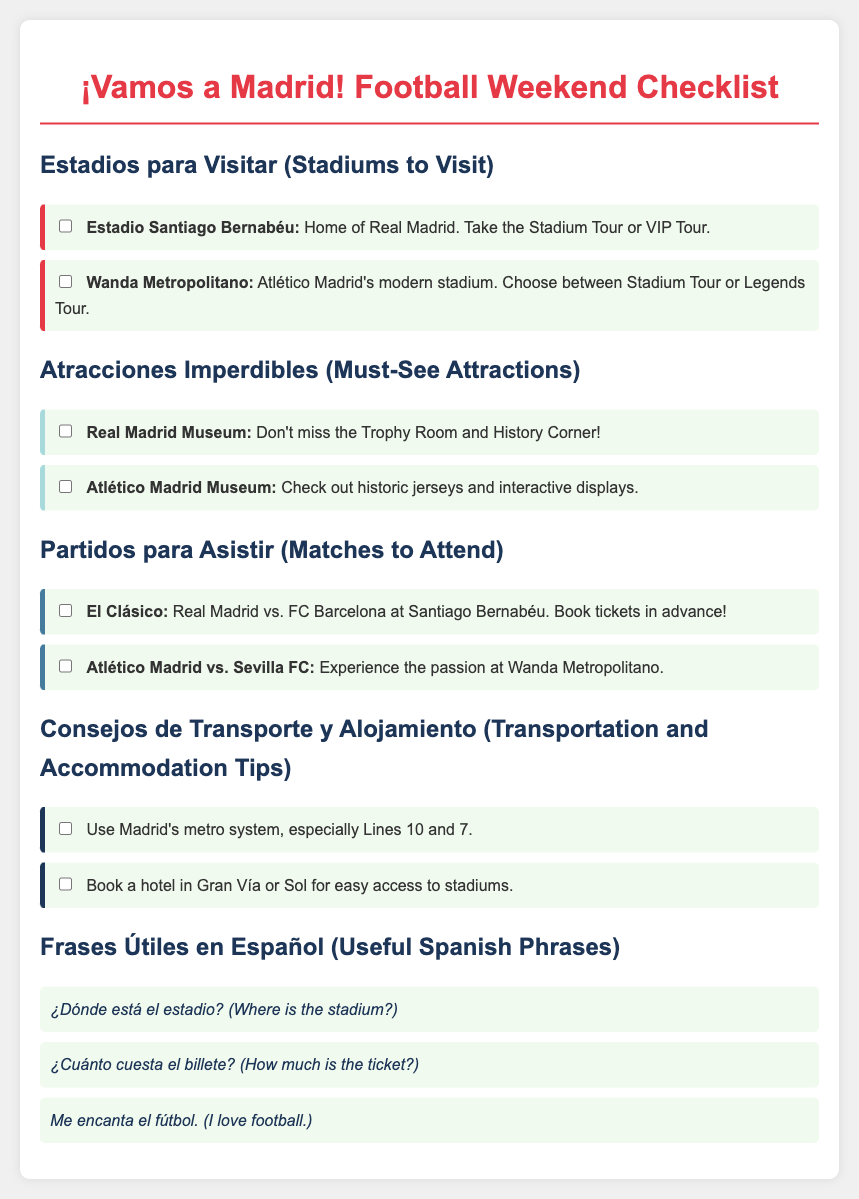What is the home stadium of Real Madrid? The document states that Santiago Bernabéu is the home of Real Madrid.
Answer: Estadio Santiago Bernabéu Which two stadiums are mentioned to visit? The document lists Estadio Santiago Bernabéu and Wanda Metropolitano as stadiums to visit.
Answer: Estadio Santiago Bernabéu and Wanda Metropolitano What is a must-see attraction related to Real Madrid? The document indicates that the Real Madrid Museum is a must-see attraction with specific highlights.
Answer: Real Madrid Museum Which famous match takes place at Santiago Bernabéu? The document mentions El Clásico as the famous match that takes place at Santiago Bernabéu.
Answer: El Clásico What tip does the document give regarding transportation? The document advises using Madrid's metro system, particularly highlighting specific lines.
Answer: Use Madrid's metro system How should one book accommodation for easy stadium access? The document suggests booking a hotel in certain areas for convenience in accessing stadiums.
Answer: Gran Vía or Sol What useful phrase translates to "I love football"? The document provides the phrase "Me encanta el fútbol" as a useful translation.
Answer: Me encanta el fútbol What kind of tour is available at Wanda Metropolitano? The document mentions that one can choose between a Stadium Tour or a Legends Tour at Wanda Metropolitano.
Answer: Stadium Tour or Legends Tour 